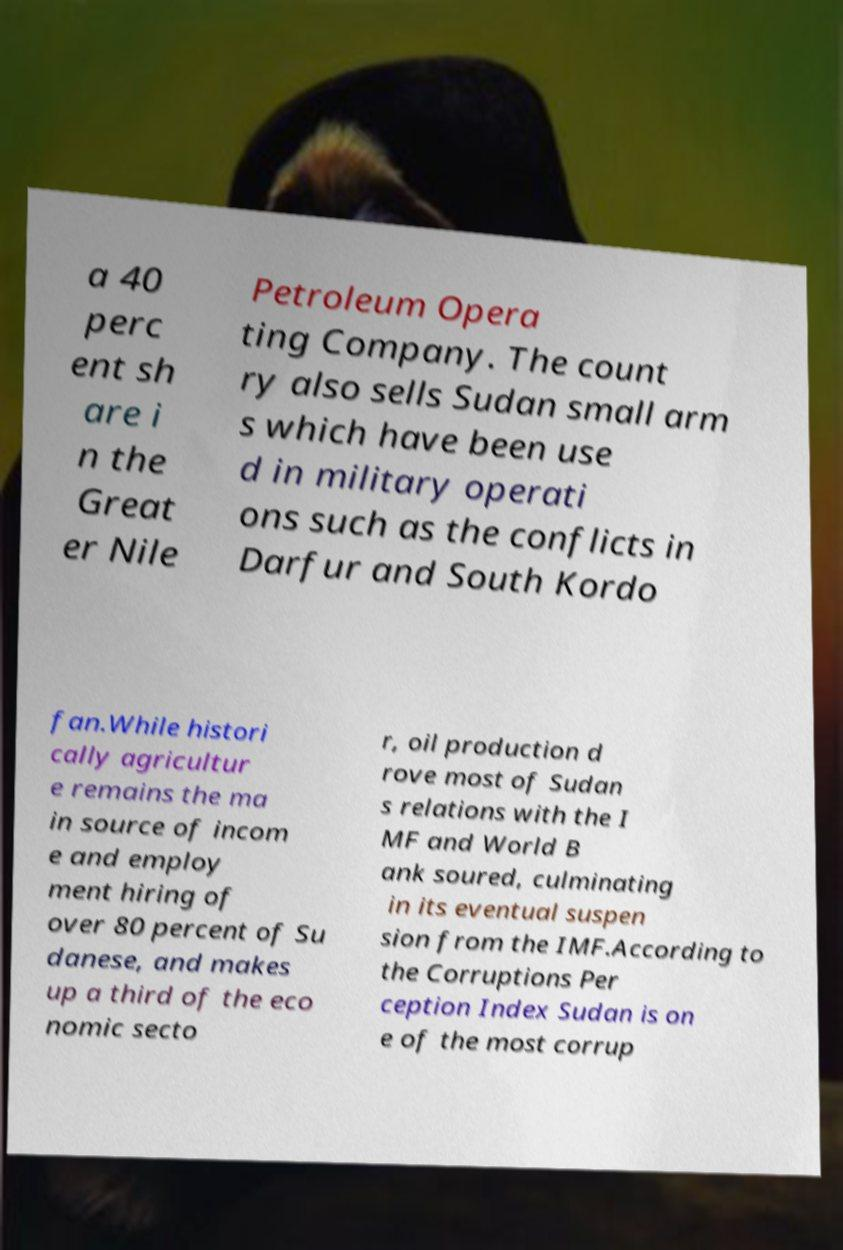Can you accurately transcribe the text from the provided image for me? a 40 perc ent sh are i n the Great er Nile Petroleum Opera ting Company. The count ry also sells Sudan small arm s which have been use d in military operati ons such as the conflicts in Darfur and South Kordo fan.While histori cally agricultur e remains the ma in source of incom e and employ ment hiring of over 80 percent of Su danese, and makes up a third of the eco nomic secto r, oil production d rove most of Sudan s relations with the I MF and World B ank soured, culminating in its eventual suspen sion from the IMF.According to the Corruptions Per ception Index Sudan is on e of the most corrup 